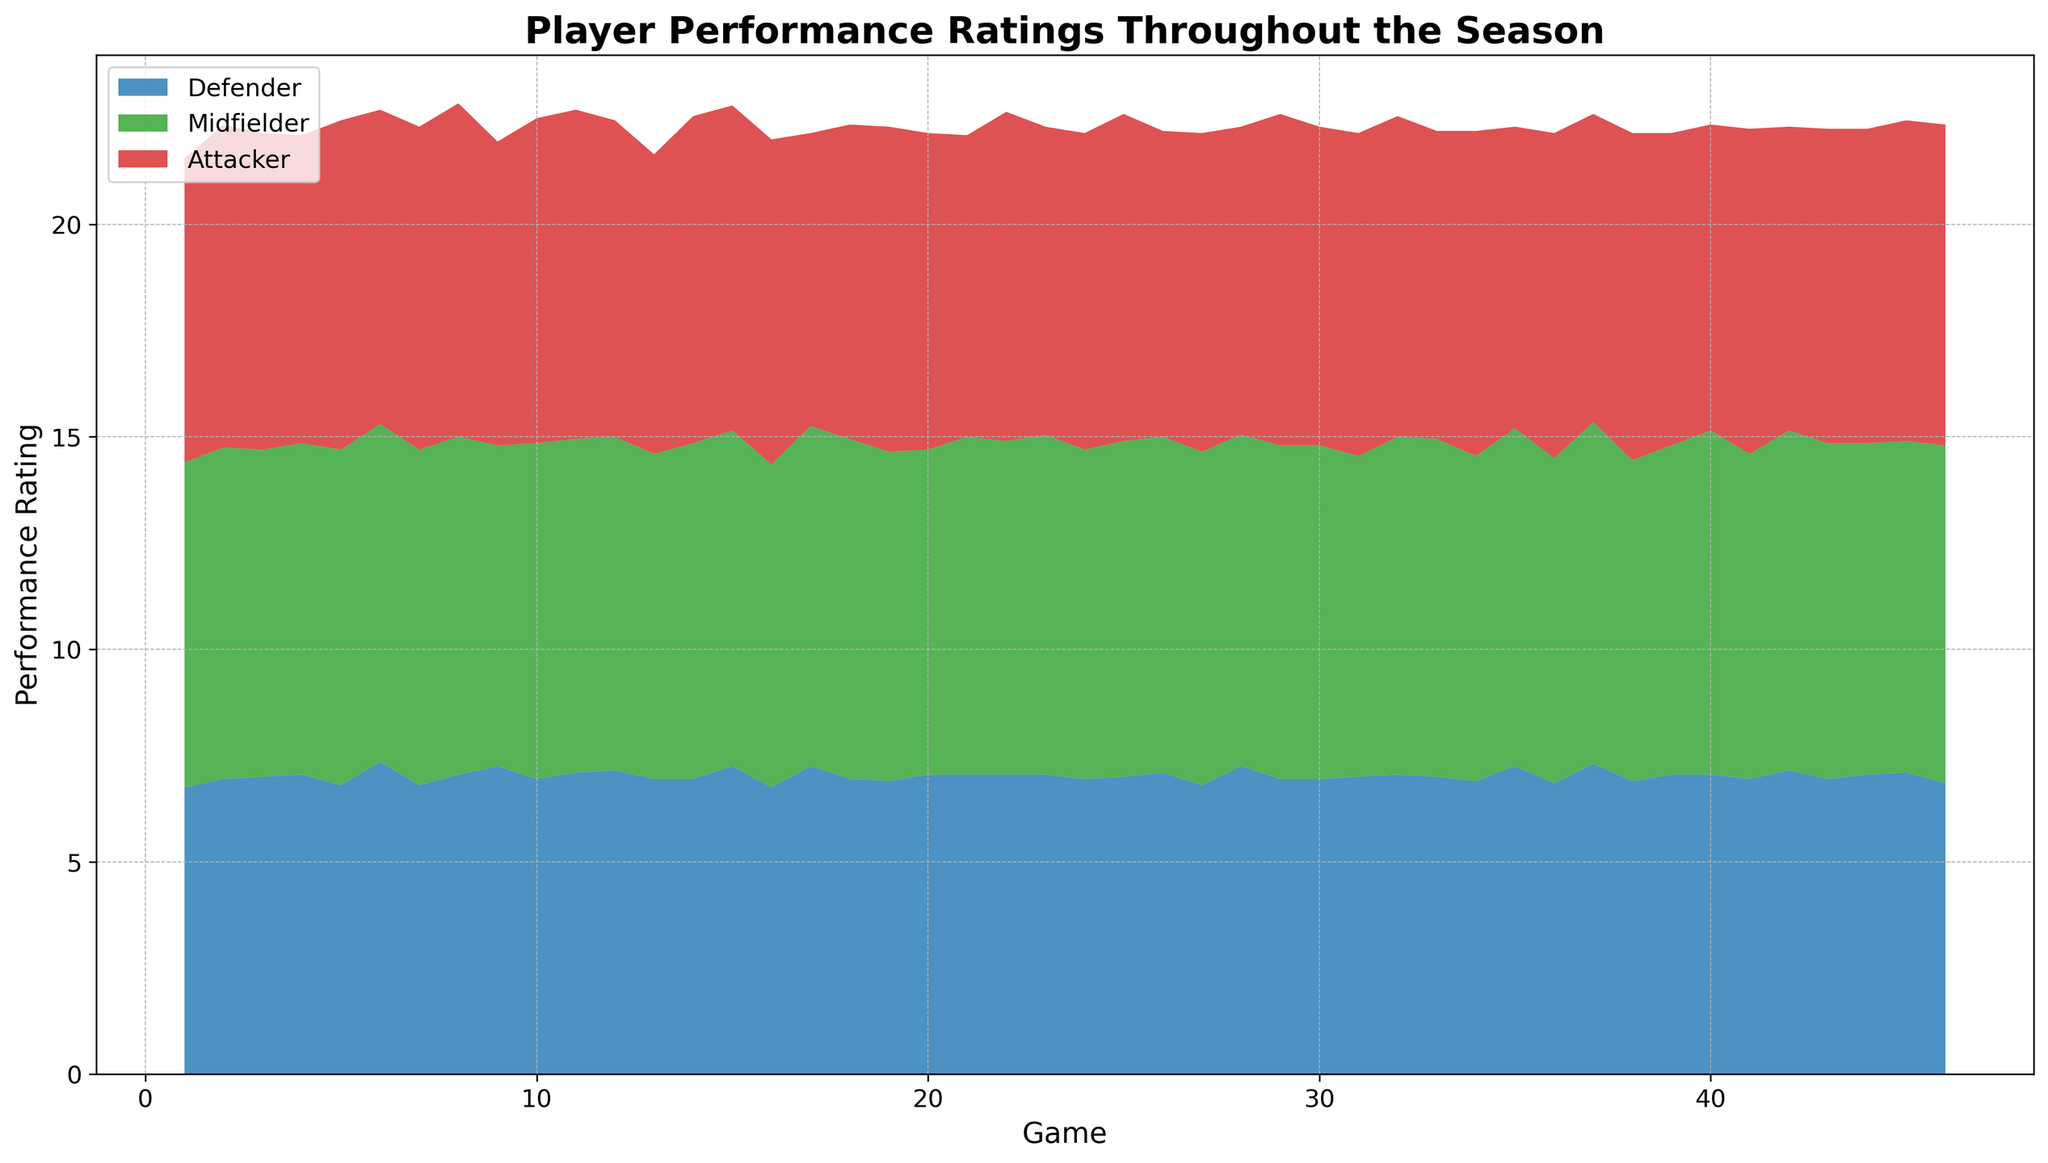How does the average performance rating of defenders compare to attackers across the season? To find this, calculate the average rating for defenders and attackers across all games from the figure. Sum up the performance ratings for each group and divide by the number of games.
Answer: Defenders have a slightly lower average rating than attackers During which game did midfielders show their highest performance? Look at the area chart and identify the game where the green area representing midfielders reaches its highest peak.
Answer: Game 42 Which position had the most consistent performance ratings throughout the season? Examine the relative heights and stability of the areas (blue for defenders, green for midfielders, and red for attackers). The position with the least fluctuation is the most consistent.
Answer: Midfielders How do the ratings of attackers in Game 30 compare to those in Game 36? Locate the red areas corresponding to Game 30 and Game 36 and compare their heights.
Answer: Attackers performed slightly better in Game 36 than in Game 30 What is the trend in the defenders' ratings from Game 20 to Game 30? Follow the blue area from Game 20 to Game 30, noting the changes in height to identify the trend.
Answer: Generally increasing What is the average performance rating of midfielders from Game 10 to Game 20? Sum the heights of the green area from Game 10 to Game 20 and divide by the number of games (11).
Answer: Approximately 8.0 Which game shows the widest gap between attackers' and midfielders' performance? Find the game where the height difference between the red and green areas is the greatest.
Answer: Game 16 In which game did defenders perform better than attackers for the first time? Scan through the games in order from the start until the blue area becomes higher than the red area.
Answer: Game 1 